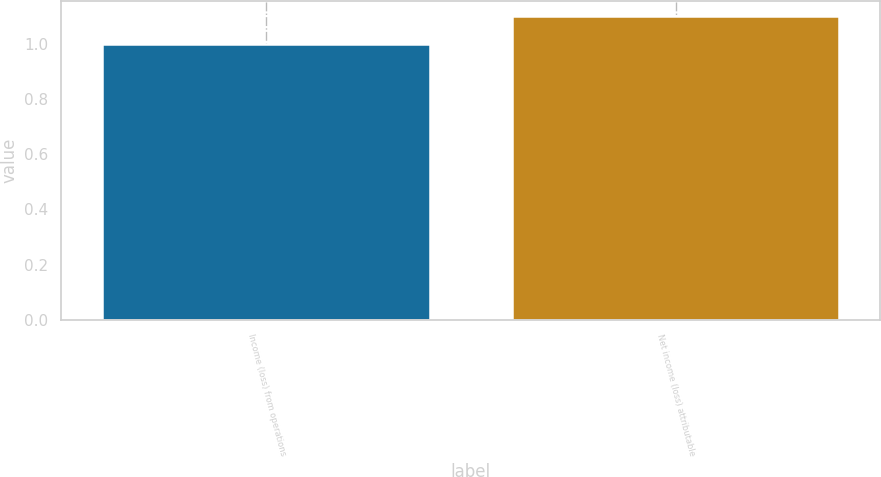<chart> <loc_0><loc_0><loc_500><loc_500><bar_chart><fcel>Income (loss) from operations<fcel>Net income (loss) attributable<nl><fcel>1<fcel>1.1<nl></chart> 